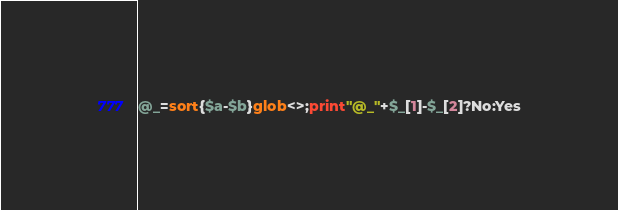Convert code to text. <code><loc_0><loc_0><loc_500><loc_500><_Perl_>@_=sort{$a-$b}glob<>;print"@_"+$_[1]-$_[2]?No:Yes</code> 